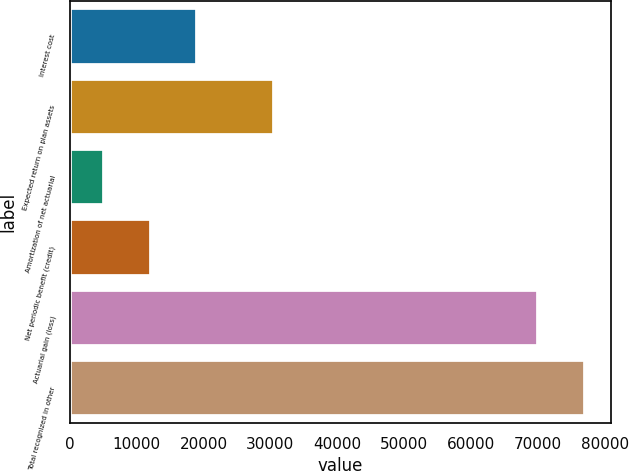<chart> <loc_0><loc_0><loc_500><loc_500><bar_chart><fcel>Interest cost<fcel>Expected return on plan assets<fcel>Amortization of net actuarial<fcel>Net periodic benefit (credit)<fcel>Actuarial gain (loss)<fcel>Total recognized in other<nl><fcel>19091<fcel>30480<fcel>5078<fcel>12084.5<fcel>70065<fcel>77071.5<nl></chart> 